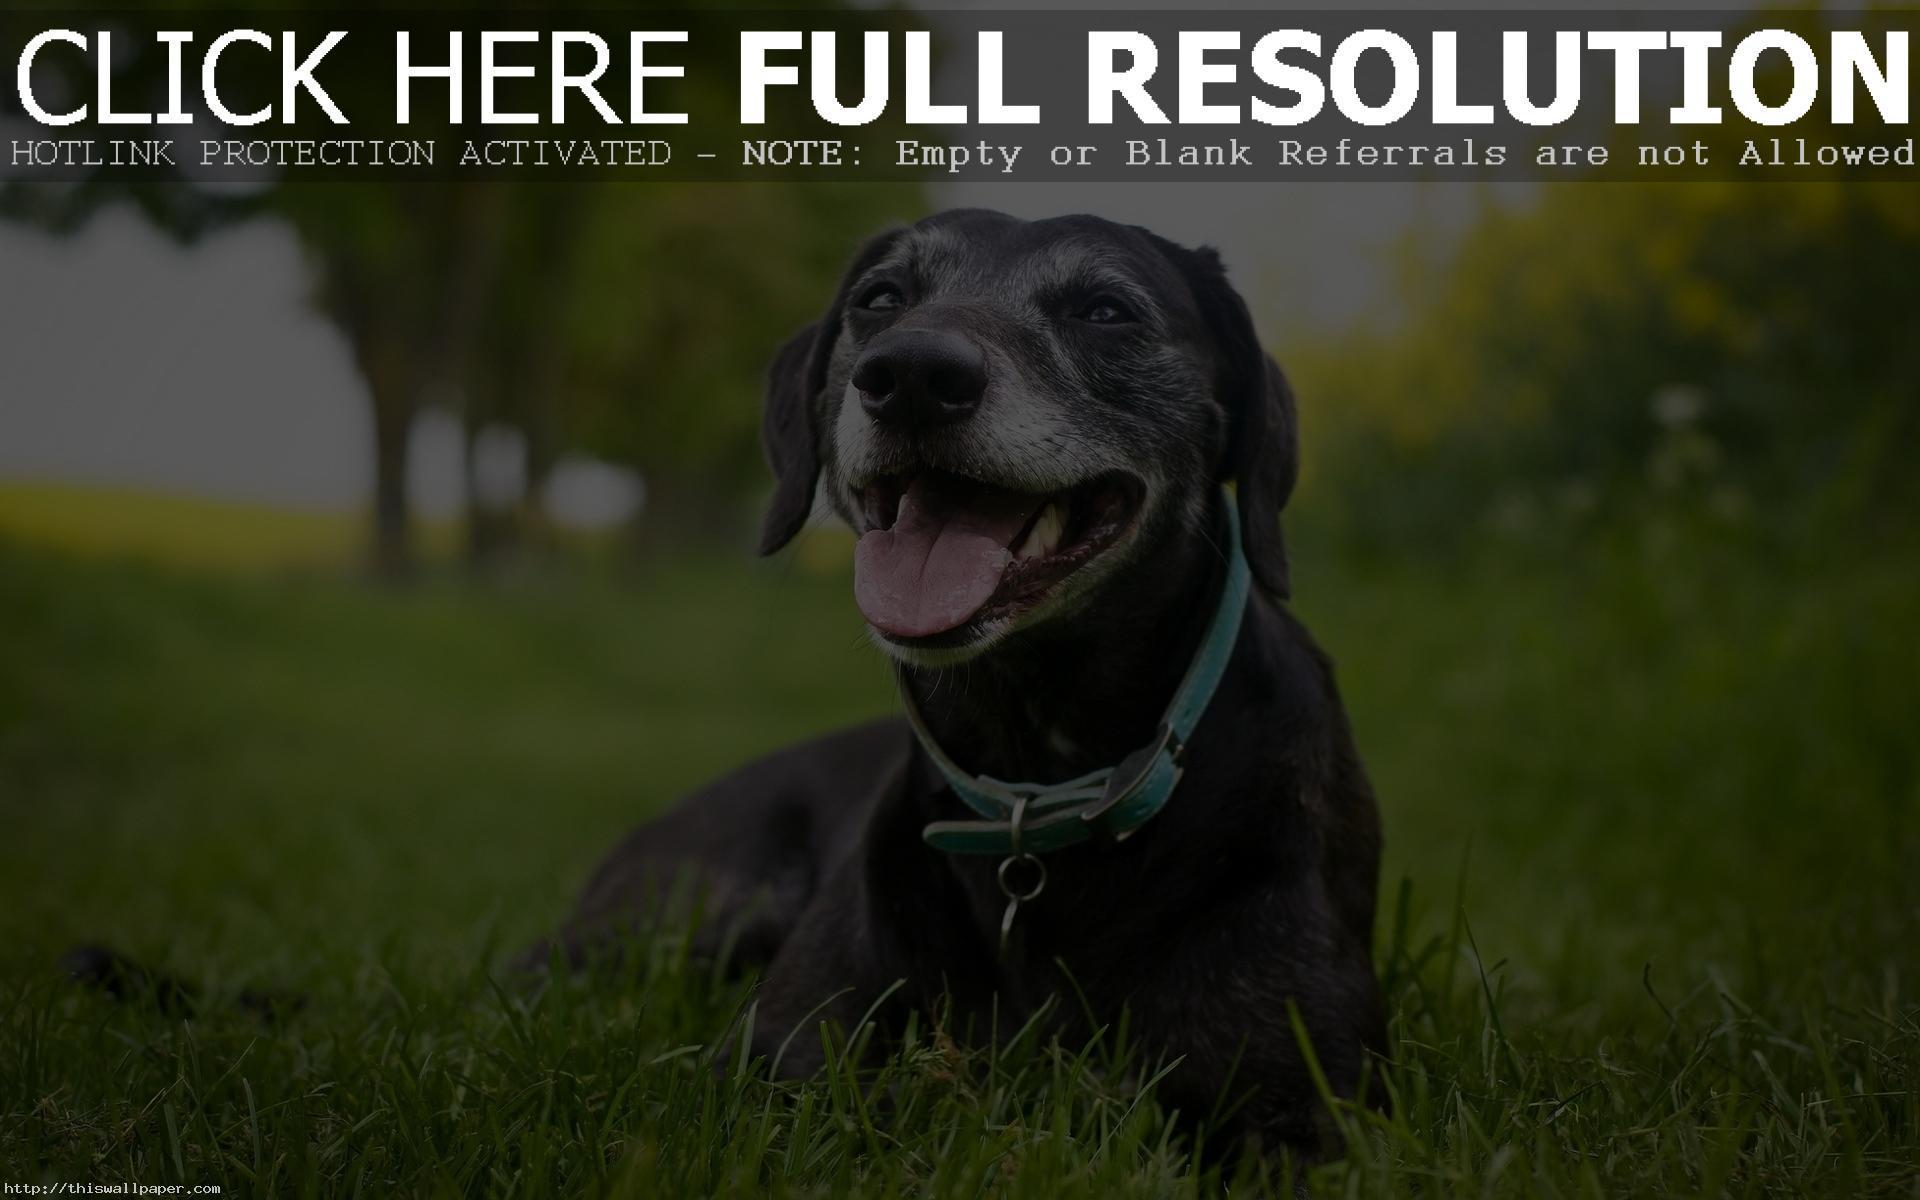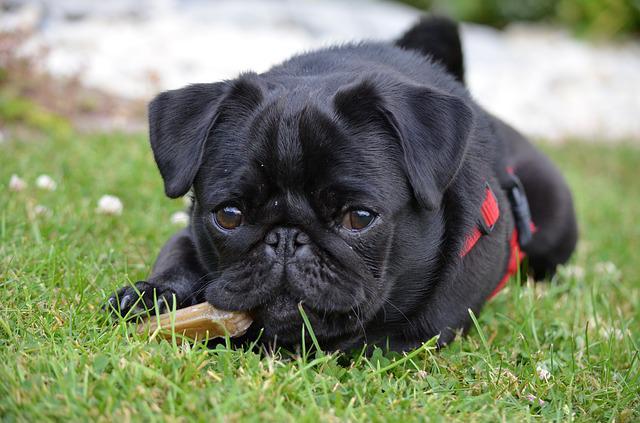The first image is the image on the left, the second image is the image on the right. Assess this claim about the two images: "In one image there is one black pug and at least one flower visible". Correct or not? Answer yes or no. No. The first image is the image on the left, the second image is the image on the right. Analyze the images presented: Is the assertion "An image features two different-colored pug dogs posing together in the grass." valid? Answer yes or no. No. 